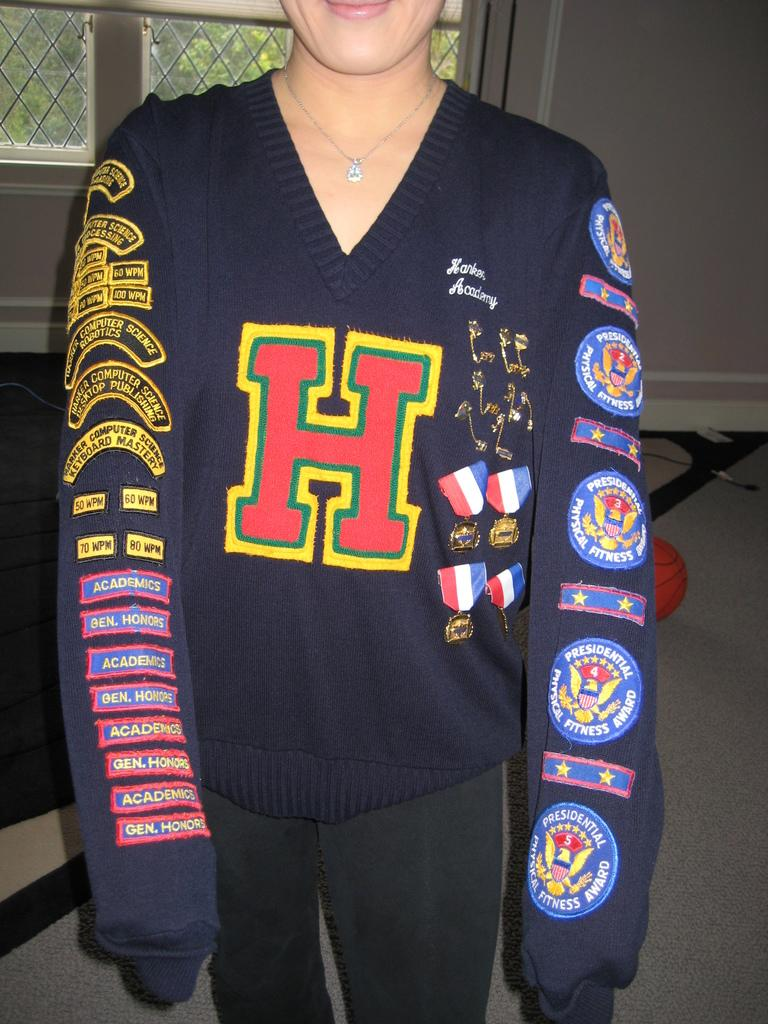<image>
Create a compact narrative representing the image presented. female wearing top with H in middle and on one sleeve patches for presidential physical fitness award and other sleeve academics gen honors and marker computer science keyboard mastery 